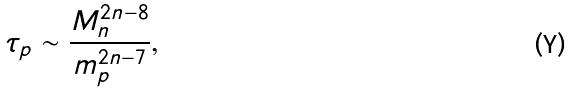Convert formula to latex. <formula><loc_0><loc_0><loc_500><loc_500>\tau _ { p } \sim \frac { M _ { n } ^ { 2 n - 8 } } { m _ { p } ^ { 2 n - 7 } } ,</formula> 